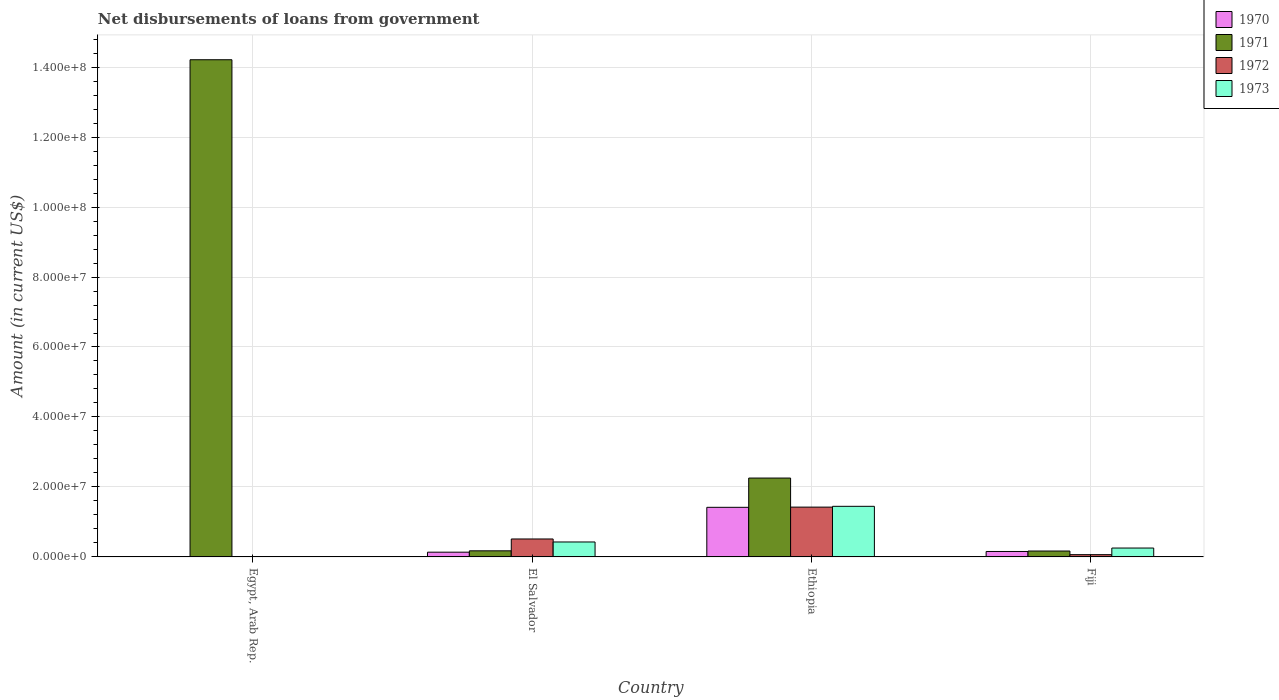How many different coloured bars are there?
Your answer should be compact. 4. Are the number of bars per tick equal to the number of legend labels?
Your answer should be very brief. No. Are the number of bars on each tick of the X-axis equal?
Your response must be concise. No. How many bars are there on the 1st tick from the right?
Offer a terse response. 4. What is the label of the 4th group of bars from the left?
Give a very brief answer. Fiji. In how many cases, is the number of bars for a given country not equal to the number of legend labels?
Provide a succinct answer. 1. What is the amount of loan disbursed from government in 1971 in Fiji?
Offer a terse response. 1.69e+06. Across all countries, what is the maximum amount of loan disbursed from government in 1971?
Make the answer very short. 1.42e+08. Across all countries, what is the minimum amount of loan disbursed from government in 1970?
Your response must be concise. 0. In which country was the amount of loan disbursed from government in 1970 maximum?
Offer a terse response. Ethiopia. What is the total amount of loan disbursed from government in 1970 in the graph?
Provide a succinct answer. 1.71e+07. What is the difference between the amount of loan disbursed from government in 1973 in El Salvador and that in Ethiopia?
Your answer should be very brief. -1.02e+07. What is the difference between the amount of loan disbursed from government in 1972 in Fiji and the amount of loan disbursed from government in 1970 in Egypt, Arab Rep.?
Provide a succinct answer. 6.49e+05. What is the average amount of loan disbursed from government in 1972 per country?
Your answer should be very brief. 5.00e+06. What is the difference between the amount of loan disbursed from government of/in 1973 and amount of loan disbursed from government of/in 1970 in Ethiopia?
Ensure brevity in your answer.  2.85e+05. What is the ratio of the amount of loan disbursed from government in 1973 in El Salvador to that in Ethiopia?
Keep it short and to the point. 0.3. Is the difference between the amount of loan disbursed from government in 1973 in El Salvador and Ethiopia greater than the difference between the amount of loan disbursed from government in 1970 in El Salvador and Ethiopia?
Offer a very short reply. Yes. What is the difference between the highest and the second highest amount of loan disbursed from government in 1970?
Offer a very short reply. 1.28e+07. What is the difference between the highest and the lowest amount of loan disbursed from government in 1971?
Ensure brevity in your answer.  1.40e+08. Is it the case that in every country, the sum of the amount of loan disbursed from government in 1971 and amount of loan disbursed from government in 1973 is greater than the sum of amount of loan disbursed from government in 1972 and amount of loan disbursed from government in 1970?
Offer a very short reply. No. Are all the bars in the graph horizontal?
Offer a very short reply. No. How many countries are there in the graph?
Offer a terse response. 4. What is the difference between two consecutive major ticks on the Y-axis?
Offer a terse response. 2.00e+07. Are the values on the major ticks of Y-axis written in scientific E-notation?
Provide a succinct answer. Yes. Does the graph contain any zero values?
Your response must be concise. Yes. Where does the legend appear in the graph?
Give a very brief answer. Top right. How many legend labels are there?
Offer a very short reply. 4. What is the title of the graph?
Offer a terse response. Net disbursements of loans from government. Does "1986" appear as one of the legend labels in the graph?
Give a very brief answer. No. What is the label or title of the X-axis?
Your answer should be very brief. Country. What is the Amount (in current US$) in 1971 in Egypt, Arab Rep.?
Give a very brief answer. 1.42e+08. What is the Amount (in current US$) in 1972 in Egypt, Arab Rep.?
Provide a succinct answer. 0. What is the Amount (in current US$) of 1973 in Egypt, Arab Rep.?
Your answer should be compact. 0. What is the Amount (in current US$) in 1970 in El Salvador?
Provide a succinct answer. 1.36e+06. What is the Amount (in current US$) of 1971 in El Salvador?
Provide a succinct answer. 1.74e+06. What is the Amount (in current US$) of 1972 in El Salvador?
Offer a terse response. 5.13e+06. What is the Amount (in current US$) in 1973 in El Salvador?
Offer a terse response. 4.27e+06. What is the Amount (in current US$) of 1970 in Ethiopia?
Give a very brief answer. 1.42e+07. What is the Amount (in current US$) of 1971 in Ethiopia?
Make the answer very short. 2.25e+07. What is the Amount (in current US$) in 1972 in Ethiopia?
Make the answer very short. 1.42e+07. What is the Amount (in current US$) of 1973 in Ethiopia?
Keep it short and to the point. 1.45e+07. What is the Amount (in current US$) of 1970 in Fiji?
Offer a very short reply. 1.56e+06. What is the Amount (in current US$) of 1971 in Fiji?
Provide a short and direct response. 1.69e+06. What is the Amount (in current US$) of 1972 in Fiji?
Offer a very short reply. 6.49e+05. What is the Amount (in current US$) of 1973 in Fiji?
Ensure brevity in your answer.  2.54e+06. Across all countries, what is the maximum Amount (in current US$) of 1970?
Ensure brevity in your answer.  1.42e+07. Across all countries, what is the maximum Amount (in current US$) in 1971?
Offer a terse response. 1.42e+08. Across all countries, what is the maximum Amount (in current US$) of 1972?
Give a very brief answer. 1.42e+07. Across all countries, what is the maximum Amount (in current US$) of 1973?
Provide a short and direct response. 1.45e+07. Across all countries, what is the minimum Amount (in current US$) of 1970?
Keep it short and to the point. 0. Across all countries, what is the minimum Amount (in current US$) in 1971?
Ensure brevity in your answer.  1.69e+06. Across all countries, what is the minimum Amount (in current US$) in 1972?
Provide a succinct answer. 0. Across all countries, what is the minimum Amount (in current US$) of 1973?
Your answer should be compact. 0. What is the total Amount (in current US$) of 1970 in the graph?
Keep it short and to the point. 1.71e+07. What is the total Amount (in current US$) in 1971 in the graph?
Provide a succinct answer. 1.68e+08. What is the total Amount (in current US$) in 1972 in the graph?
Give a very brief answer. 2.00e+07. What is the total Amount (in current US$) in 1973 in the graph?
Offer a terse response. 2.13e+07. What is the difference between the Amount (in current US$) of 1971 in Egypt, Arab Rep. and that in El Salvador?
Provide a short and direct response. 1.40e+08. What is the difference between the Amount (in current US$) in 1971 in Egypt, Arab Rep. and that in Ethiopia?
Make the answer very short. 1.20e+08. What is the difference between the Amount (in current US$) in 1971 in Egypt, Arab Rep. and that in Fiji?
Make the answer very short. 1.40e+08. What is the difference between the Amount (in current US$) in 1970 in El Salvador and that in Ethiopia?
Your answer should be compact. -1.28e+07. What is the difference between the Amount (in current US$) of 1971 in El Salvador and that in Ethiopia?
Give a very brief answer. -2.08e+07. What is the difference between the Amount (in current US$) of 1972 in El Salvador and that in Ethiopia?
Your answer should be very brief. -9.10e+06. What is the difference between the Amount (in current US$) in 1973 in El Salvador and that in Ethiopia?
Provide a succinct answer. -1.02e+07. What is the difference between the Amount (in current US$) in 1970 in El Salvador and that in Fiji?
Provide a succinct answer. -2.03e+05. What is the difference between the Amount (in current US$) of 1971 in El Salvador and that in Fiji?
Offer a very short reply. 5.70e+04. What is the difference between the Amount (in current US$) in 1972 in El Salvador and that in Fiji?
Provide a succinct answer. 4.48e+06. What is the difference between the Amount (in current US$) in 1973 in El Salvador and that in Fiji?
Provide a succinct answer. 1.73e+06. What is the difference between the Amount (in current US$) in 1970 in Ethiopia and that in Fiji?
Your answer should be compact. 1.26e+07. What is the difference between the Amount (in current US$) of 1971 in Ethiopia and that in Fiji?
Your answer should be compact. 2.09e+07. What is the difference between the Amount (in current US$) of 1972 in Ethiopia and that in Fiji?
Offer a terse response. 1.36e+07. What is the difference between the Amount (in current US$) of 1973 in Ethiopia and that in Fiji?
Ensure brevity in your answer.  1.19e+07. What is the difference between the Amount (in current US$) in 1971 in Egypt, Arab Rep. and the Amount (in current US$) in 1972 in El Salvador?
Keep it short and to the point. 1.37e+08. What is the difference between the Amount (in current US$) of 1971 in Egypt, Arab Rep. and the Amount (in current US$) of 1973 in El Salvador?
Your response must be concise. 1.38e+08. What is the difference between the Amount (in current US$) in 1971 in Egypt, Arab Rep. and the Amount (in current US$) in 1972 in Ethiopia?
Ensure brevity in your answer.  1.28e+08. What is the difference between the Amount (in current US$) of 1971 in Egypt, Arab Rep. and the Amount (in current US$) of 1973 in Ethiopia?
Provide a succinct answer. 1.28e+08. What is the difference between the Amount (in current US$) in 1971 in Egypt, Arab Rep. and the Amount (in current US$) in 1972 in Fiji?
Provide a succinct answer. 1.41e+08. What is the difference between the Amount (in current US$) in 1971 in Egypt, Arab Rep. and the Amount (in current US$) in 1973 in Fiji?
Your answer should be compact. 1.40e+08. What is the difference between the Amount (in current US$) in 1970 in El Salvador and the Amount (in current US$) in 1971 in Ethiopia?
Your answer should be compact. -2.12e+07. What is the difference between the Amount (in current US$) in 1970 in El Salvador and the Amount (in current US$) in 1972 in Ethiopia?
Your answer should be very brief. -1.29e+07. What is the difference between the Amount (in current US$) of 1970 in El Salvador and the Amount (in current US$) of 1973 in Ethiopia?
Provide a short and direct response. -1.31e+07. What is the difference between the Amount (in current US$) in 1971 in El Salvador and the Amount (in current US$) in 1972 in Ethiopia?
Make the answer very short. -1.25e+07. What is the difference between the Amount (in current US$) in 1971 in El Salvador and the Amount (in current US$) in 1973 in Ethiopia?
Ensure brevity in your answer.  -1.27e+07. What is the difference between the Amount (in current US$) of 1972 in El Salvador and the Amount (in current US$) of 1973 in Ethiopia?
Ensure brevity in your answer.  -9.33e+06. What is the difference between the Amount (in current US$) of 1970 in El Salvador and the Amount (in current US$) of 1971 in Fiji?
Make the answer very short. -3.31e+05. What is the difference between the Amount (in current US$) of 1970 in El Salvador and the Amount (in current US$) of 1972 in Fiji?
Provide a succinct answer. 7.08e+05. What is the difference between the Amount (in current US$) of 1970 in El Salvador and the Amount (in current US$) of 1973 in Fiji?
Your answer should be very brief. -1.18e+06. What is the difference between the Amount (in current US$) of 1971 in El Salvador and the Amount (in current US$) of 1972 in Fiji?
Your answer should be very brief. 1.10e+06. What is the difference between the Amount (in current US$) in 1971 in El Salvador and the Amount (in current US$) in 1973 in Fiji?
Offer a very short reply. -7.94e+05. What is the difference between the Amount (in current US$) of 1972 in El Salvador and the Amount (in current US$) of 1973 in Fiji?
Your answer should be very brief. 2.59e+06. What is the difference between the Amount (in current US$) in 1970 in Ethiopia and the Amount (in current US$) in 1971 in Fiji?
Your answer should be very brief. 1.25e+07. What is the difference between the Amount (in current US$) of 1970 in Ethiopia and the Amount (in current US$) of 1972 in Fiji?
Make the answer very short. 1.35e+07. What is the difference between the Amount (in current US$) in 1970 in Ethiopia and the Amount (in current US$) in 1973 in Fiji?
Offer a terse response. 1.16e+07. What is the difference between the Amount (in current US$) of 1971 in Ethiopia and the Amount (in current US$) of 1972 in Fiji?
Offer a very short reply. 2.19e+07. What is the difference between the Amount (in current US$) in 1971 in Ethiopia and the Amount (in current US$) in 1973 in Fiji?
Offer a very short reply. 2.00e+07. What is the difference between the Amount (in current US$) in 1972 in Ethiopia and the Amount (in current US$) in 1973 in Fiji?
Your answer should be compact. 1.17e+07. What is the average Amount (in current US$) in 1970 per country?
Make the answer very short. 4.27e+06. What is the average Amount (in current US$) in 1971 per country?
Provide a succinct answer. 4.20e+07. What is the average Amount (in current US$) of 1972 per country?
Provide a succinct answer. 5.00e+06. What is the average Amount (in current US$) of 1973 per country?
Your answer should be very brief. 5.32e+06. What is the difference between the Amount (in current US$) of 1970 and Amount (in current US$) of 1971 in El Salvador?
Provide a succinct answer. -3.88e+05. What is the difference between the Amount (in current US$) of 1970 and Amount (in current US$) of 1972 in El Salvador?
Ensure brevity in your answer.  -3.77e+06. What is the difference between the Amount (in current US$) of 1970 and Amount (in current US$) of 1973 in El Salvador?
Make the answer very short. -2.92e+06. What is the difference between the Amount (in current US$) of 1971 and Amount (in current US$) of 1972 in El Salvador?
Your answer should be very brief. -3.39e+06. What is the difference between the Amount (in current US$) in 1971 and Amount (in current US$) in 1973 in El Salvador?
Give a very brief answer. -2.53e+06. What is the difference between the Amount (in current US$) in 1972 and Amount (in current US$) in 1973 in El Salvador?
Provide a succinct answer. 8.59e+05. What is the difference between the Amount (in current US$) in 1970 and Amount (in current US$) in 1971 in Ethiopia?
Offer a terse response. -8.36e+06. What is the difference between the Amount (in current US$) of 1970 and Amount (in current US$) of 1972 in Ethiopia?
Offer a terse response. -5.80e+04. What is the difference between the Amount (in current US$) of 1970 and Amount (in current US$) of 1973 in Ethiopia?
Provide a short and direct response. -2.85e+05. What is the difference between the Amount (in current US$) of 1971 and Amount (in current US$) of 1972 in Ethiopia?
Ensure brevity in your answer.  8.31e+06. What is the difference between the Amount (in current US$) of 1971 and Amount (in current US$) of 1973 in Ethiopia?
Offer a very short reply. 8.08e+06. What is the difference between the Amount (in current US$) of 1972 and Amount (in current US$) of 1973 in Ethiopia?
Offer a very short reply. -2.27e+05. What is the difference between the Amount (in current US$) in 1970 and Amount (in current US$) in 1971 in Fiji?
Give a very brief answer. -1.28e+05. What is the difference between the Amount (in current US$) of 1970 and Amount (in current US$) of 1972 in Fiji?
Your answer should be very brief. 9.11e+05. What is the difference between the Amount (in current US$) in 1970 and Amount (in current US$) in 1973 in Fiji?
Provide a succinct answer. -9.79e+05. What is the difference between the Amount (in current US$) of 1971 and Amount (in current US$) of 1972 in Fiji?
Offer a terse response. 1.04e+06. What is the difference between the Amount (in current US$) in 1971 and Amount (in current US$) in 1973 in Fiji?
Offer a terse response. -8.51e+05. What is the difference between the Amount (in current US$) of 1972 and Amount (in current US$) of 1973 in Fiji?
Ensure brevity in your answer.  -1.89e+06. What is the ratio of the Amount (in current US$) in 1971 in Egypt, Arab Rep. to that in El Salvador?
Your response must be concise. 81.43. What is the ratio of the Amount (in current US$) in 1971 in Egypt, Arab Rep. to that in Ethiopia?
Keep it short and to the point. 6.3. What is the ratio of the Amount (in current US$) in 1971 in Egypt, Arab Rep. to that in Fiji?
Your response must be concise. 84.18. What is the ratio of the Amount (in current US$) of 1970 in El Salvador to that in Ethiopia?
Your answer should be compact. 0.1. What is the ratio of the Amount (in current US$) in 1971 in El Salvador to that in Ethiopia?
Provide a succinct answer. 0.08. What is the ratio of the Amount (in current US$) of 1972 in El Salvador to that in Ethiopia?
Give a very brief answer. 0.36. What is the ratio of the Amount (in current US$) of 1973 in El Salvador to that in Ethiopia?
Ensure brevity in your answer.  0.3. What is the ratio of the Amount (in current US$) of 1970 in El Salvador to that in Fiji?
Your answer should be very brief. 0.87. What is the ratio of the Amount (in current US$) in 1971 in El Salvador to that in Fiji?
Your answer should be compact. 1.03. What is the ratio of the Amount (in current US$) of 1972 in El Salvador to that in Fiji?
Your answer should be compact. 7.91. What is the ratio of the Amount (in current US$) in 1973 in El Salvador to that in Fiji?
Provide a short and direct response. 1.68. What is the ratio of the Amount (in current US$) in 1970 in Ethiopia to that in Fiji?
Offer a very short reply. 9.09. What is the ratio of the Amount (in current US$) in 1971 in Ethiopia to that in Fiji?
Provide a short and direct response. 13.35. What is the ratio of the Amount (in current US$) of 1972 in Ethiopia to that in Fiji?
Make the answer very short. 21.94. What is the ratio of the Amount (in current US$) in 1973 in Ethiopia to that in Fiji?
Provide a short and direct response. 5.7. What is the difference between the highest and the second highest Amount (in current US$) in 1970?
Keep it short and to the point. 1.26e+07. What is the difference between the highest and the second highest Amount (in current US$) in 1971?
Your answer should be compact. 1.20e+08. What is the difference between the highest and the second highest Amount (in current US$) of 1972?
Ensure brevity in your answer.  9.10e+06. What is the difference between the highest and the second highest Amount (in current US$) of 1973?
Make the answer very short. 1.02e+07. What is the difference between the highest and the lowest Amount (in current US$) in 1970?
Give a very brief answer. 1.42e+07. What is the difference between the highest and the lowest Amount (in current US$) of 1971?
Make the answer very short. 1.40e+08. What is the difference between the highest and the lowest Amount (in current US$) of 1972?
Your answer should be compact. 1.42e+07. What is the difference between the highest and the lowest Amount (in current US$) of 1973?
Your answer should be compact. 1.45e+07. 